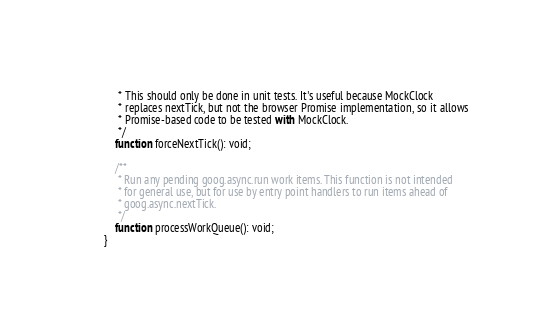Convert code to text. <code><loc_0><loc_0><loc_500><loc_500><_TypeScript_>     * This should only be done in unit tests. It's useful because MockClock
     * replaces nextTick, but not the browser Promise implementation, so it allows
     * Promise-based code to be tested with MockClock.
     */
    function forceNextTick(): void;

    /**
     * Run any pending goog.async.run work items. This function is not intended
     * for general use, but for use by entry point handlers to run items ahead of
     * goog.async.nextTick.
     */
    function processWorkQueue(): void;
}
</code> 